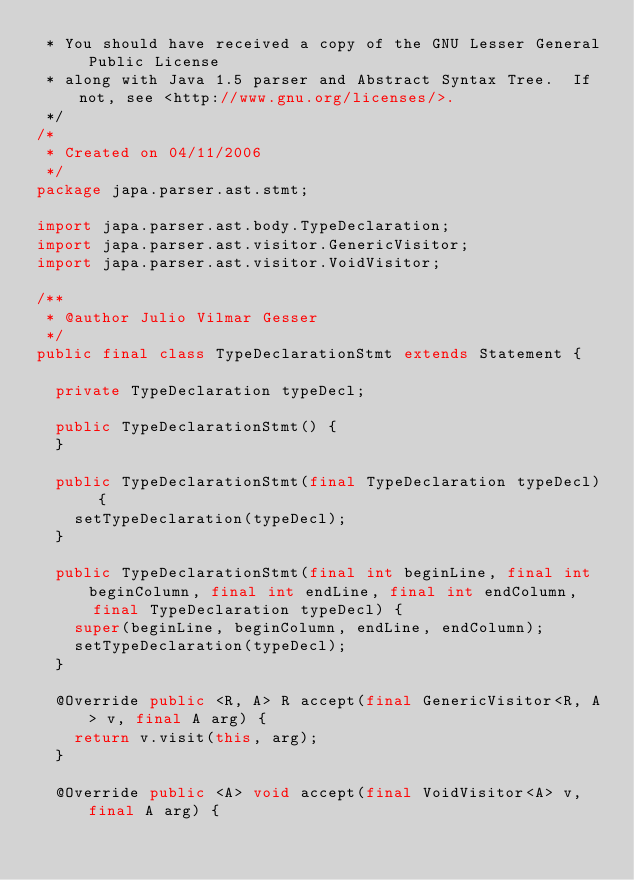Convert code to text. <code><loc_0><loc_0><loc_500><loc_500><_Java_> * You should have received a copy of the GNU Lesser General Public License
 * along with Java 1.5 parser and Abstract Syntax Tree.  If not, see <http://www.gnu.org/licenses/>.
 */
/*
 * Created on 04/11/2006
 */
package japa.parser.ast.stmt;

import japa.parser.ast.body.TypeDeclaration;
import japa.parser.ast.visitor.GenericVisitor;
import japa.parser.ast.visitor.VoidVisitor;

/**
 * @author Julio Vilmar Gesser
 */
public final class TypeDeclarationStmt extends Statement {

	private TypeDeclaration typeDecl;

	public TypeDeclarationStmt() {
	}

	public TypeDeclarationStmt(final TypeDeclaration typeDecl) {
		setTypeDeclaration(typeDecl);
	}

	public TypeDeclarationStmt(final int beginLine, final int beginColumn, final int endLine, final int endColumn,
			final TypeDeclaration typeDecl) {
		super(beginLine, beginColumn, endLine, endColumn);
		setTypeDeclaration(typeDecl);
	}

	@Override public <R, A> R accept(final GenericVisitor<R, A> v, final A arg) {
		return v.visit(this, arg);
	}

	@Override public <A> void accept(final VoidVisitor<A> v, final A arg) {</code> 